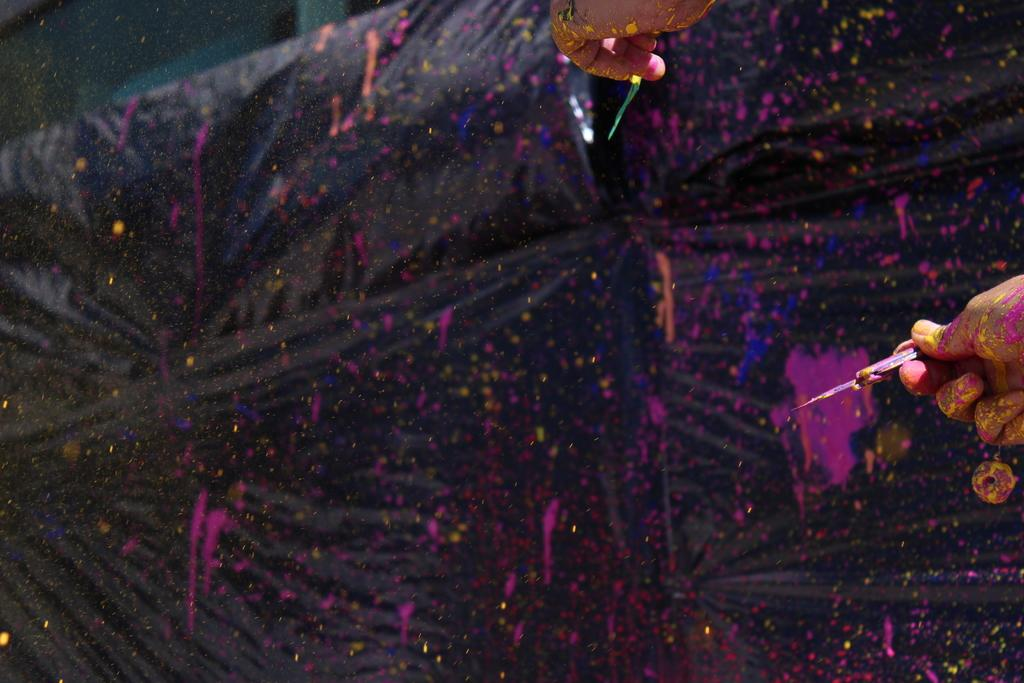What is the person in the image doing? The person in the image is painting. What color is the cloth that the person is painting on? The cloth being painted on is black. What colors can be seen in the image besides the color of the cloth? Pink and blue colors are present in the image. What type of stone is being used as a punishment tool in the image? There is no stone or punishment tool present in the image; it features a person painting on a black cloth. What is the nature of the love depicted in the image? There is no depiction of love in the image; it features a person painting on a black cloth. 